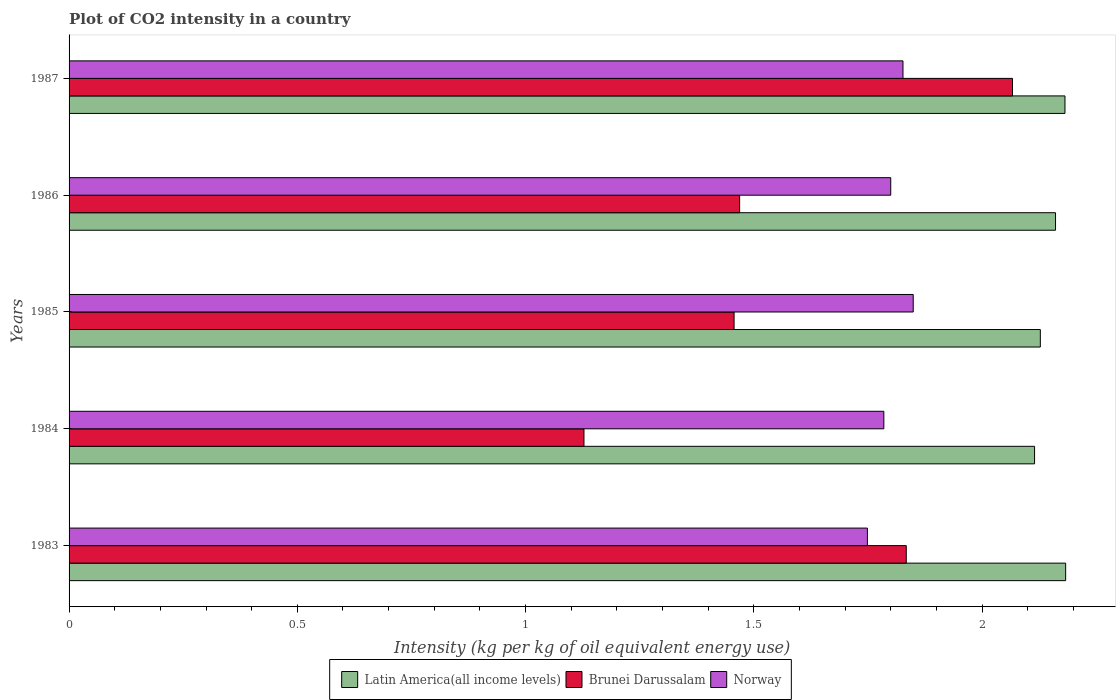How many different coloured bars are there?
Make the answer very short. 3. How many groups of bars are there?
Provide a short and direct response. 5. Are the number of bars per tick equal to the number of legend labels?
Give a very brief answer. Yes. How many bars are there on the 5th tick from the top?
Offer a very short reply. 3. How many bars are there on the 1st tick from the bottom?
Your answer should be compact. 3. What is the CO2 intensity in in Latin America(all income levels) in 1986?
Keep it short and to the point. 2.16. Across all years, what is the maximum CO2 intensity in in Latin America(all income levels)?
Make the answer very short. 2.18. Across all years, what is the minimum CO2 intensity in in Brunei Darussalam?
Your answer should be very brief. 1.13. In which year was the CO2 intensity in in Brunei Darussalam minimum?
Offer a very short reply. 1984. What is the total CO2 intensity in in Brunei Darussalam in the graph?
Provide a short and direct response. 7.95. What is the difference between the CO2 intensity in in Norway in 1983 and that in 1987?
Offer a very short reply. -0.08. What is the difference between the CO2 intensity in in Brunei Darussalam in 1983 and the CO2 intensity in in Latin America(all income levels) in 1986?
Your answer should be very brief. -0.33. What is the average CO2 intensity in in Latin America(all income levels) per year?
Your response must be concise. 2.15. In the year 1986, what is the difference between the CO2 intensity in in Latin America(all income levels) and CO2 intensity in in Norway?
Your answer should be very brief. 0.36. In how many years, is the CO2 intensity in in Latin America(all income levels) greater than 1.3 kg?
Give a very brief answer. 5. What is the ratio of the CO2 intensity in in Latin America(all income levels) in 1984 to that in 1985?
Your response must be concise. 0.99. Is the difference between the CO2 intensity in in Latin America(all income levels) in 1983 and 1987 greater than the difference between the CO2 intensity in in Norway in 1983 and 1987?
Provide a short and direct response. Yes. What is the difference between the highest and the second highest CO2 intensity in in Latin America(all income levels)?
Keep it short and to the point. 0. What is the difference between the highest and the lowest CO2 intensity in in Latin America(all income levels)?
Offer a very short reply. 0.07. Is it the case that in every year, the sum of the CO2 intensity in in Brunei Darussalam and CO2 intensity in in Latin America(all income levels) is greater than the CO2 intensity in in Norway?
Provide a short and direct response. Yes. How many bars are there?
Your response must be concise. 15. How many years are there in the graph?
Your answer should be very brief. 5. Does the graph contain grids?
Ensure brevity in your answer.  No. Where does the legend appear in the graph?
Offer a terse response. Bottom center. How are the legend labels stacked?
Your answer should be very brief. Horizontal. What is the title of the graph?
Keep it short and to the point. Plot of CO2 intensity in a country. Does "Vanuatu" appear as one of the legend labels in the graph?
Your answer should be very brief. No. What is the label or title of the X-axis?
Offer a terse response. Intensity (kg per kg of oil equivalent energy use). What is the label or title of the Y-axis?
Offer a terse response. Years. What is the Intensity (kg per kg of oil equivalent energy use) in Latin America(all income levels) in 1983?
Your response must be concise. 2.18. What is the Intensity (kg per kg of oil equivalent energy use) in Brunei Darussalam in 1983?
Keep it short and to the point. 1.83. What is the Intensity (kg per kg of oil equivalent energy use) in Norway in 1983?
Your answer should be very brief. 1.75. What is the Intensity (kg per kg of oil equivalent energy use) of Latin America(all income levels) in 1984?
Give a very brief answer. 2.11. What is the Intensity (kg per kg of oil equivalent energy use) of Brunei Darussalam in 1984?
Keep it short and to the point. 1.13. What is the Intensity (kg per kg of oil equivalent energy use) of Norway in 1984?
Your answer should be compact. 1.78. What is the Intensity (kg per kg of oil equivalent energy use) in Latin America(all income levels) in 1985?
Your response must be concise. 2.13. What is the Intensity (kg per kg of oil equivalent energy use) in Brunei Darussalam in 1985?
Make the answer very short. 1.46. What is the Intensity (kg per kg of oil equivalent energy use) of Norway in 1985?
Keep it short and to the point. 1.85. What is the Intensity (kg per kg of oil equivalent energy use) in Latin America(all income levels) in 1986?
Your answer should be compact. 2.16. What is the Intensity (kg per kg of oil equivalent energy use) in Brunei Darussalam in 1986?
Offer a very short reply. 1.47. What is the Intensity (kg per kg of oil equivalent energy use) of Norway in 1986?
Your response must be concise. 1.8. What is the Intensity (kg per kg of oil equivalent energy use) in Latin America(all income levels) in 1987?
Offer a very short reply. 2.18. What is the Intensity (kg per kg of oil equivalent energy use) of Brunei Darussalam in 1987?
Offer a terse response. 2.07. What is the Intensity (kg per kg of oil equivalent energy use) of Norway in 1987?
Provide a short and direct response. 1.83. Across all years, what is the maximum Intensity (kg per kg of oil equivalent energy use) of Latin America(all income levels)?
Offer a very short reply. 2.18. Across all years, what is the maximum Intensity (kg per kg of oil equivalent energy use) of Brunei Darussalam?
Offer a terse response. 2.07. Across all years, what is the maximum Intensity (kg per kg of oil equivalent energy use) of Norway?
Provide a succinct answer. 1.85. Across all years, what is the minimum Intensity (kg per kg of oil equivalent energy use) of Latin America(all income levels)?
Your answer should be very brief. 2.11. Across all years, what is the minimum Intensity (kg per kg of oil equivalent energy use) in Brunei Darussalam?
Offer a terse response. 1.13. Across all years, what is the minimum Intensity (kg per kg of oil equivalent energy use) in Norway?
Your response must be concise. 1.75. What is the total Intensity (kg per kg of oil equivalent energy use) in Latin America(all income levels) in the graph?
Offer a very short reply. 10.77. What is the total Intensity (kg per kg of oil equivalent energy use) in Brunei Darussalam in the graph?
Provide a succinct answer. 7.95. What is the total Intensity (kg per kg of oil equivalent energy use) of Norway in the graph?
Offer a very short reply. 9.01. What is the difference between the Intensity (kg per kg of oil equivalent energy use) of Latin America(all income levels) in 1983 and that in 1984?
Offer a very short reply. 0.07. What is the difference between the Intensity (kg per kg of oil equivalent energy use) in Brunei Darussalam in 1983 and that in 1984?
Provide a succinct answer. 0.71. What is the difference between the Intensity (kg per kg of oil equivalent energy use) of Norway in 1983 and that in 1984?
Provide a short and direct response. -0.04. What is the difference between the Intensity (kg per kg of oil equivalent energy use) of Latin America(all income levels) in 1983 and that in 1985?
Your answer should be compact. 0.06. What is the difference between the Intensity (kg per kg of oil equivalent energy use) of Brunei Darussalam in 1983 and that in 1985?
Offer a very short reply. 0.38. What is the difference between the Intensity (kg per kg of oil equivalent energy use) in Norway in 1983 and that in 1985?
Provide a short and direct response. -0.1. What is the difference between the Intensity (kg per kg of oil equivalent energy use) of Latin America(all income levels) in 1983 and that in 1986?
Provide a short and direct response. 0.02. What is the difference between the Intensity (kg per kg of oil equivalent energy use) of Brunei Darussalam in 1983 and that in 1986?
Offer a terse response. 0.36. What is the difference between the Intensity (kg per kg of oil equivalent energy use) of Norway in 1983 and that in 1986?
Provide a short and direct response. -0.05. What is the difference between the Intensity (kg per kg of oil equivalent energy use) in Latin America(all income levels) in 1983 and that in 1987?
Offer a very short reply. 0. What is the difference between the Intensity (kg per kg of oil equivalent energy use) in Brunei Darussalam in 1983 and that in 1987?
Your response must be concise. -0.23. What is the difference between the Intensity (kg per kg of oil equivalent energy use) in Norway in 1983 and that in 1987?
Your answer should be very brief. -0.08. What is the difference between the Intensity (kg per kg of oil equivalent energy use) of Latin America(all income levels) in 1984 and that in 1985?
Ensure brevity in your answer.  -0.01. What is the difference between the Intensity (kg per kg of oil equivalent energy use) in Brunei Darussalam in 1984 and that in 1985?
Provide a short and direct response. -0.33. What is the difference between the Intensity (kg per kg of oil equivalent energy use) of Norway in 1984 and that in 1985?
Provide a succinct answer. -0.06. What is the difference between the Intensity (kg per kg of oil equivalent energy use) of Latin America(all income levels) in 1984 and that in 1986?
Provide a short and direct response. -0.05. What is the difference between the Intensity (kg per kg of oil equivalent energy use) of Brunei Darussalam in 1984 and that in 1986?
Give a very brief answer. -0.34. What is the difference between the Intensity (kg per kg of oil equivalent energy use) of Norway in 1984 and that in 1986?
Keep it short and to the point. -0.02. What is the difference between the Intensity (kg per kg of oil equivalent energy use) of Latin America(all income levels) in 1984 and that in 1987?
Provide a short and direct response. -0.07. What is the difference between the Intensity (kg per kg of oil equivalent energy use) in Brunei Darussalam in 1984 and that in 1987?
Ensure brevity in your answer.  -0.94. What is the difference between the Intensity (kg per kg of oil equivalent energy use) in Norway in 1984 and that in 1987?
Your response must be concise. -0.04. What is the difference between the Intensity (kg per kg of oil equivalent energy use) in Latin America(all income levels) in 1985 and that in 1986?
Give a very brief answer. -0.03. What is the difference between the Intensity (kg per kg of oil equivalent energy use) in Brunei Darussalam in 1985 and that in 1986?
Keep it short and to the point. -0.01. What is the difference between the Intensity (kg per kg of oil equivalent energy use) of Norway in 1985 and that in 1986?
Provide a short and direct response. 0.05. What is the difference between the Intensity (kg per kg of oil equivalent energy use) in Latin America(all income levels) in 1985 and that in 1987?
Your answer should be very brief. -0.05. What is the difference between the Intensity (kg per kg of oil equivalent energy use) in Brunei Darussalam in 1985 and that in 1987?
Give a very brief answer. -0.61. What is the difference between the Intensity (kg per kg of oil equivalent energy use) in Norway in 1985 and that in 1987?
Your answer should be compact. 0.02. What is the difference between the Intensity (kg per kg of oil equivalent energy use) of Latin America(all income levels) in 1986 and that in 1987?
Offer a terse response. -0.02. What is the difference between the Intensity (kg per kg of oil equivalent energy use) in Brunei Darussalam in 1986 and that in 1987?
Offer a very short reply. -0.6. What is the difference between the Intensity (kg per kg of oil equivalent energy use) of Norway in 1986 and that in 1987?
Keep it short and to the point. -0.03. What is the difference between the Intensity (kg per kg of oil equivalent energy use) of Latin America(all income levels) in 1983 and the Intensity (kg per kg of oil equivalent energy use) of Brunei Darussalam in 1984?
Give a very brief answer. 1.06. What is the difference between the Intensity (kg per kg of oil equivalent energy use) in Latin America(all income levels) in 1983 and the Intensity (kg per kg of oil equivalent energy use) in Norway in 1984?
Your answer should be very brief. 0.4. What is the difference between the Intensity (kg per kg of oil equivalent energy use) of Brunei Darussalam in 1983 and the Intensity (kg per kg of oil equivalent energy use) of Norway in 1984?
Offer a very short reply. 0.05. What is the difference between the Intensity (kg per kg of oil equivalent energy use) in Latin America(all income levels) in 1983 and the Intensity (kg per kg of oil equivalent energy use) in Brunei Darussalam in 1985?
Your answer should be very brief. 0.73. What is the difference between the Intensity (kg per kg of oil equivalent energy use) of Latin America(all income levels) in 1983 and the Intensity (kg per kg of oil equivalent energy use) of Norway in 1985?
Keep it short and to the point. 0.33. What is the difference between the Intensity (kg per kg of oil equivalent energy use) in Brunei Darussalam in 1983 and the Intensity (kg per kg of oil equivalent energy use) in Norway in 1985?
Offer a very short reply. -0.02. What is the difference between the Intensity (kg per kg of oil equivalent energy use) in Latin America(all income levels) in 1983 and the Intensity (kg per kg of oil equivalent energy use) in Brunei Darussalam in 1986?
Make the answer very short. 0.71. What is the difference between the Intensity (kg per kg of oil equivalent energy use) of Latin America(all income levels) in 1983 and the Intensity (kg per kg of oil equivalent energy use) of Norway in 1986?
Keep it short and to the point. 0.38. What is the difference between the Intensity (kg per kg of oil equivalent energy use) of Brunei Darussalam in 1983 and the Intensity (kg per kg of oil equivalent energy use) of Norway in 1986?
Provide a short and direct response. 0.03. What is the difference between the Intensity (kg per kg of oil equivalent energy use) in Latin America(all income levels) in 1983 and the Intensity (kg per kg of oil equivalent energy use) in Brunei Darussalam in 1987?
Keep it short and to the point. 0.12. What is the difference between the Intensity (kg per kg of oil equivalent energy use) in Latin America(all income levels) in 1983 and the Intensity (kg per kg of oil equivalent energy use) in Norway in 1987?
Give a very brief answer. 0.36. What is the difference between the Intensity (kg per kg of oil equivalent energy use) in Brunei Darussalam in 1983 and the Intensity (kg per kg of oil equivalent energy use) in Norway in 1987?
Your response must be concise. 0.01. What is the difference between the Intensity (kg per kg of oil equivalent energy use) in Latin America(all income levels) in 1984 and the Intensity (kg per kg of oil equivalent energy use) in Brunei Darussalam in 1985?
Provide a short and direct response. 0.66. What is the difference between the Intensity (kg per kg of oil equivalent energy use) of Latin America(all income levels) in 1984 and the Intensity (kg per kg of oil equivalent energy use) of Norway in 1985?
Provide a succinct answer. 0.27. What is the difference between the Intensity (kg per kg of oil equivalent energy use) of Brunei Darussalam in 1984 and the Intensity (kg per kg of oil equivalent energy use) of Norway in 1985?
Your answer should be compact. -0.72. What is the difference between the Intensity (kg per kg of oil equivalent energy use) of Latin America(all income levels) in 1984 and the Intensity (kg per kg of oil equivalent energy use) of Brunei Darussalam in 1986?
Your answer should be very brief. 0.65. What is the difference between the Intensity (kg per kg of oil equivalent energy use) of Latin America(all income levels) in 1984 and the Intensity (kg per kg of oil equivalent energy use) of Norway in 1986?
Offer a terse response. 0.32. What is the difference between the Intensity (kg per kg of oil equivalent energy use) of Brunei Darussalam in 1984 and the Intensity (kg per kg of oil equivalent energy use) of Norway in 1986?
Offer a terse response. -0.67. What is the difference between the Intensity (kg per kg of oil equivalent energy use) of Latin America(all income levels) in 1984 and the Intensity (kg per kg of oil equivalent energy use) of Brunei Darussalam in 1987?
Your response must be concise. 0.05. What is the difference between the Intensity (kg per kg of oil equivalent energy use) in Latin America(all income levels) in 1984 and the Intensity (kg per kg of oil equivalent energy use) in Norway in 1987?
Make the answer very short. 0.29. What is the difference between the Intensity (kg per kg of oil equivalent energy use) in Brunei Darussalam in 1984 and the Intensity (kg per kg of oil equivalent energy use) in Norway in 1987?
Offer a very short reply. -0.7. What is the difference between the Intensity (kg per kg of oil equivalent energy use) in Latin America(all income levels) in 1985 and the Intensity (kg per kg of oil equivalent energy use) in Brunei Darussalam in 1986?
Provide a succinct answer. 0.66. What is the difference between the Intensity (kg per kg of oil equivalent energy use) of Latin America(all income levels) in 1985 and the Intensity (kg per kg of oil equivalent energy use) of Norway in 1986?
Provide a succinct answer. 0.33. What is the difference between the Intensity (kg per kg of oil equivalent energy use) of Brunei Darussalam in 1985 and the Intensity (kg per kg of oil equivalent energy use) of Norway in 1986?
Make the answer very short. -0.34. What is the difference between the Intensity (kg per kg of oil equivalent energy use) in Latin America(all income levels) in 1985 and the Intensity (kg per kg of oil equivalent energy use) in Brunei Darussalam in 1987?
Give a very brief answer. 0.06. What is the difference between the Intensity (kg per kg of oil equivalent energy use) of Latin America(all income levels) in 1985 and the Intensity (kg per kg of oil equivalent energy use) of Norway in 1987?
Give a very brief answer. 0.3. What is the difference between the Intensity (kg per kg of oil equivalent energy use) of Brunei Darussalam in 1985 and the Intensity (kg per kg of oil equivalent energy use) of Norway in 1987?
Your answer should be compact. -0.37. What is the difference between the Intensity (kg per kg of oil equivalent energy use) in Latin America(all income levels) in 1986 and the Intensity (kg per kg of oil equivalent energy use) in Brunei Darussalam in 1987?
Provide a succinct answer. 0.09. What is the difference between the Intensity (kg per kg of oil equivalent energy use) in Latin America(all income levels) in 1986 and the Intensity (kg per kg of oil equivalent energy use) in Norway in 1987?
Your response must be concise. 0.33. What is the difference between the Intensity (kg per kg of oil equivalent energy use) in Brunei Darussalam in 1986 and the Intensity (kg per kg of oil equivalent energy use) in Norway in 1987?
Your answer should be compact. -0.36. What is the average Intensity (kg per kg of oil equivalent energy use) in Latin America(all income levels) per year?
Offer a very short reply. 2.15. What is the average Intensity (kg per kg of oil equivalent energy use) in Brunei Darussalam per year?
Provide a short and direct response. 1.59. What is the average Intensity (kg per kg of oil equivalent energy use) in Norway per year?
Give a very brief answer. 1.8. In the year 1983, what is the difference between the Intensity (kg per kg of oil equivalent energy use) of Latin America(all income levels) and Intensity (kg per kg of oil equivalent energy use) of Brunei Darussalam?
Make the answer very short. 0.35. In the year 1983, what is the difference between the Intensity (kg per kg of oil equivalent energy use) of Latin America(all income levels) and Intensity (kg per kg of oil equivalent energy use) of Norway?
Give a very brief answer. 0.43. In the year 1983, what is the difference between the Intensity (kg per kg of oil equivalent energy use) in Brunei Darussalam and Intensity (kg per kg of oil equivalent energy use) in Norway?
Provide a succinct answer. 0.09. In the year 1984, what is the difference between the Intensity (kg per kg of oil equivalent energy use) of Latin America(all income levels) and Intensity (kg per kg of oil equivalent energy use) of Norway?
Offer a very short reply. 0.33. In the year 1984, what is the difference between the Intensity (kg per kg of oil equivalent energy use) of Brunei Darussalam and Intensity (kg per kg of oil equivalent energy use) of Norway?
Provide a short and direct response. -0.66. In the year 1985, what is the difference between the Intensity (kg per kg of oil equivalent energy use) in Latin America(all income levels) and Intensity (kg per kg of oil equivalent energy use) in Brunei Darussalam?
Offer a terse response. 0.67. In the year 1985, what is the difference between the Intensity (kg per kg of oil equivalent energy use) of Latin America(all income levels) and Intensity (kg per kg of oil equivalent energy use) of Norway?
Offer a very short reply. 0.28. In the year 1985, what is the difference between the Intensity (kg per kg of oil equivalent energy use) in Brunei Darussalam and Intensity (kg per kg of oil equivalent energy use) in Norway?
Provide a short and direct response. -0.39. In the year 1986, what is the difference between the Intensity (kg per kg of oil equivalent energy use) in Latin America(all income levels) and Intensity (kg per kg of oil equivalent energy use) in Brunei Darussalam?
Your response must be concise. 0.69. In the year 1986, what is the difference between the Intensity (kg per kg of oil equivalent energy use) of Latin America(all income levels) and Intensity (kg per kg of oil equivalent energy use) of Norway?
Offer a terse response. 0.36. In the year 1986, what is the difference between the Intensity (kg per kg of oil equivalent energy use) in Brunei Darussalam and Intensity (kg per kg of oil equivalent energy use) in Norway?
Offer a very short reply. -0.33. In the year 1987, what is the difference between the Intensity (kg per kg of oil equivalent energy use) in Latin America(all income levels) and Intensity (kg per kg of oil equivalent energy use) in Brunei Darussalam?
Provide a short and direct response. 0.12. In the year 1987, what is the difference between the Intensity (kg per kg of oil equivalent energy use) in Latin America(all income levels) and Intensity (kg per kg of oil equivalent energy use) in Norway?
Offer a terse response. 0.35. In the year 1987, what is the difference between the Intensity (kg per kg of oil equivalent energy use) in Brunei Darussalam and Intensity (kg per kg of oil equivalent energy use) in Norway?
Make the answer very short. 0.24. What is the ratio of the Intensity (kg per kg of oil equivalent energy use) of Latin America(all income levels) in 1983 to that in 1984?
Your answer should be very brief. 1.03. What is the ratio of the Intensity (kg per kg of oil equivalent energy use) of Brunei Darussalam in 1983 to that in 1984?
Your answer should be compact. 1.63. What is the ratio of the Intensity (kg per kg of oil equivalent energy use) of Norway in 1983 to that in 1984?
Keep it short and to the point. 0.98. What is the ratio of the Intensity (kg per kg of oil equivalent energy use) in Latin America(all income levels) in 1983 to that in 1985?
Keep it short and to the point. 1.03. What is the ratio of the Intensity (kg per kg of oil equivalent energy use) of Brunei Darussalam in 1983 to that in 1985?
Ensure brevity in your answer.  1.26. What is the ratio of the Intensity (kg per kg of oil equivalent energy use) in Norway in 1983 to that in 1985?
Give a very brief answer. 0.95. What is the ratio of the Intensity (kg per kg of oil equivalent energy use) in Latin America(all income levels) in 1983 to that in 1986?
Your answer should be compact. 1.01. What is the ratio of the Intensity (kg per kg of oil equivalent energy use) in Brunei Darussalam in 1983 to that in 1986?
Your answer should be compact. 1.25. What is the ratio of the Intensity (kg per kg of oil equivalent energy use) in Norway in 1983 to that in 1986?
Provide a short and direct response. 0.97. What is the ratio of the Intensity (kg per kg of oil equivalent energy use) of Brunei Darussalam in 1983 to that in 1987?
Provide a short and direct response. 0.89. What is the ratio of the Intensity (kg per kg of oil equivalent energy use) in Norway in 1983 to that in 1987?
Ensure brevity in your answer.  0.96. What is the ratio of the Intensity (kg per kg of oil equivalent energy use) of Latin America(all income levels) in 1984 to that in 1985?
Your answer should be compact. 0.99. What is the ratio of the Intensity (kg per kg of oil equivalent energy use) in Brunei Darussalam in 1984 to that in 1985?
Keep it short and to the point. 0.77. What is the ratio of the Intensity (kg per kg of oil equivalent energy use) of Norway in 1984 to that in 1985?
Ensure brevity in your answer.  0.97. What is the ratio of the Intensity (kg per kg of oil equivalent energy use) of Latin America(all income levels) in 1984 to that in 1986?
Your answer should be compact. 0.98. What is the ratio of the Intensity (kg per kg of oil equivalent energy use) in Brunei Darussalam in 1984 to that in 1986?
Offer a terse response. 0.77. What is the ratio of the Intensity (kg per kg of oil equivalent energy use) in Latin America(all income levels) in 1984 to that in 1987?
Ensure brevity in your answer.  0.97. What is the ratio of the Intensity (kg per kg of oil equivalent energy use) in Brunei Darussalam in 1984 to that in 1987?
Your answer should be compact. 0.55. What is the ratio of the Intensity (kg per kg of oil equivalent energy use) of Norway in 1984 to that in 1987?
Provide a short and direct response. 0.98. What is the ratio of the Intensity (kg per kg of oil equivalent energy use) of Latin America(all income levels) in 1985 to that in 1986?
Offer a terse response. 0.98. What is the ratio of the Intensity (kg per kg of oil equivalent energy use) in Norway in 1985 to that in 1986?
Keep it short and to the point. 1.03. What is the ratio of the Intensity (kg per kg of oil equivalent energy use) of Latin America(all income levels) in 1985 to that in 1987?
Your answer should be compact. 0.98. What is the ratio of the Intensity (kg per kg of oil equivalent energy use) in Brunei Darussalam in 1985 to that in 1987?
Your answer should be compact. 0.7. What is the ratio of the Intensity (kg per kg of oil equivalent energy use) in Norway in 1985 to that in 1987?
Give a very brief answer. 1.01. What is the ratio of the Intensity (kg per kg of oil equivalent energy use) of Brunei Darussalam in 1986 to that in 1987?
Provide a succinct answer. 0.71. What is the ratio of the Intensity (kg per kg of oil equivalent energy use) of Norway in 1986 to that in 1987?
Ensure brevity in your answer.  0.99. What is the difference between the highest and the second highest Intensity (kg per kg of oil equivalent energy use) of Latin America(all income levels)?
Provide a succinct answer. 0. What is the difference between the highest and the second highest Intensity (kg per kg of oil equivalent energy use) of Brunei Darussalam?
Your answer should be compact. 0.23. What is the difference between the highest and the second highest Intensity (kg per kg of oil equivalent energy use) in Norway?
Offer a very short reply. 0.02. What is the difference between the highest and the lowest Intensity (kg per kg of oil equivalent energy use) of Latin America(all income levels)?
Offer a terse response. 0.07. What is the difference between the highest and the lowest Intensity (kg per kg of oil equivalent energy use) of Brunei Darussalam?
Your answer should be very brief. 0.94. What is the difference between the highest and the lowest Intensity (kg per kg of oil equivalent energy use) in Norway?
Your answer should be compact. 0.1. 